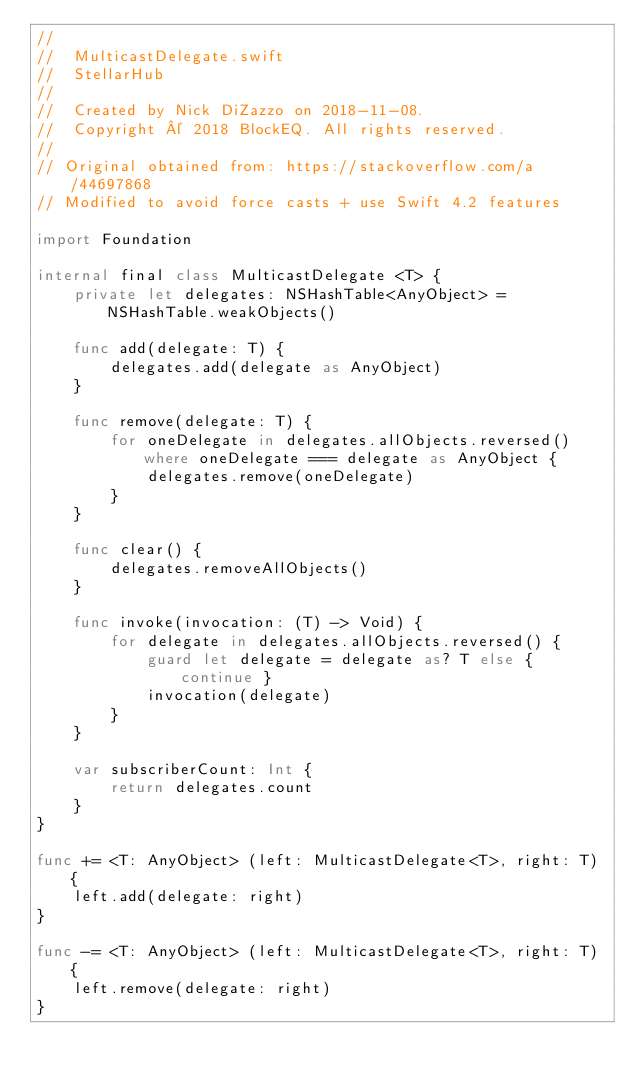Convert code to text. <code><loc_0><loc_0><loc_500><loc_500><_Swift_>//
//  MulticastDelegate.swift
//  StellarHub
//
//  Created by Nick DiZazzo on 2018-11-08.
//  Copyright © 2018 BlockEQ. All rights reserved.
//
// Original obtained from: https://stackoverflow.com/a/44697868
// Modified to avoid force casts + use Swift 4.2 features

import Foundation

internal final class MulticastDelegate <T> {
    private let delegates: NSHashTable<AnyObject> = NSHashTable.weakObjects()

    func add(delegate: T) {
        delegates.add(delegate as AnyObject)
    }

    func remove(delegate: T) {
        for oneDelegate in delegates.allObjects.reversed() where oneDelegate === delegate as AnyObject {
            delegates.remove(oneDelegate)
        }
    }

    func clear() {
        delegates.removeAllObjects()
    }

    func invoke(invocation: (T) -> Void) {
        for delegate in delegates.allObjects.reversed() {
            guard let delegate = delegate as? T else { continue }
            invocation(delegate)
        }
    }

    var subscriberCount: Int {
        return delegates.count
    }
}

func += <T: AnyObject> (left: MulticastDelegate<T>, right: T) {
    left.add(delegate: right)
}

func -= <T: AnyObject> (left: MulticastDelegate<T>, right: T) {
    left.remove(delegate: right)
}
</code> 